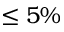Convert formula to latex. <formula><loc_0><loc_0><loc_500><loc_500>\leq 5 \%</formula> 